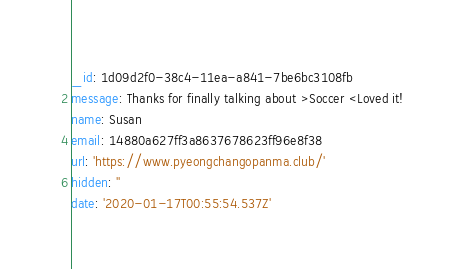<code> <loc_0><loc_0><loc_500><loc_500><_YAML_>_id: 1d09d2f0-38c4-11ea-a841-7be6bc3108fb
message: Thanks for finally talking about >Soccer <Loved it!
name: Susan
email: 14880a627ff3a8637678623ff96e8f38
url: 'https://www.pyeongchangopanma.club/'
hidden: ''
date: '2020-01-17T00:55:54.537Z'
</code> 